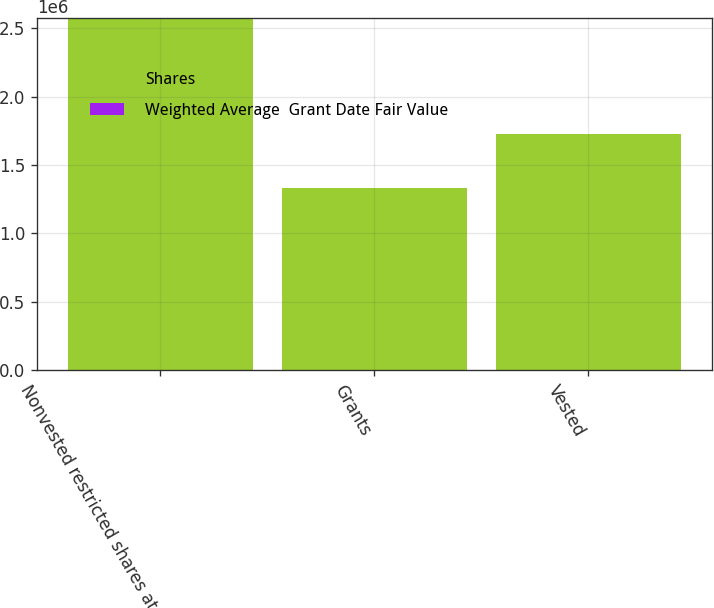<chart> <loc_0><loc_0><loc_500><loc_500><stacked_bar_chart><ecel><fcel>Nonvested restricted shares at<fcel>Grants<fcel>Vested<nl><fcel>Shares<fcel>2.57078e+06<fcel>1.33509e+06<fcel>1.72806e+06<nl><fcel>Weighted Average  Grant Date Fair Value<fcel>24.18<fcel>30.62<fcel>15.95<nl></chart> 